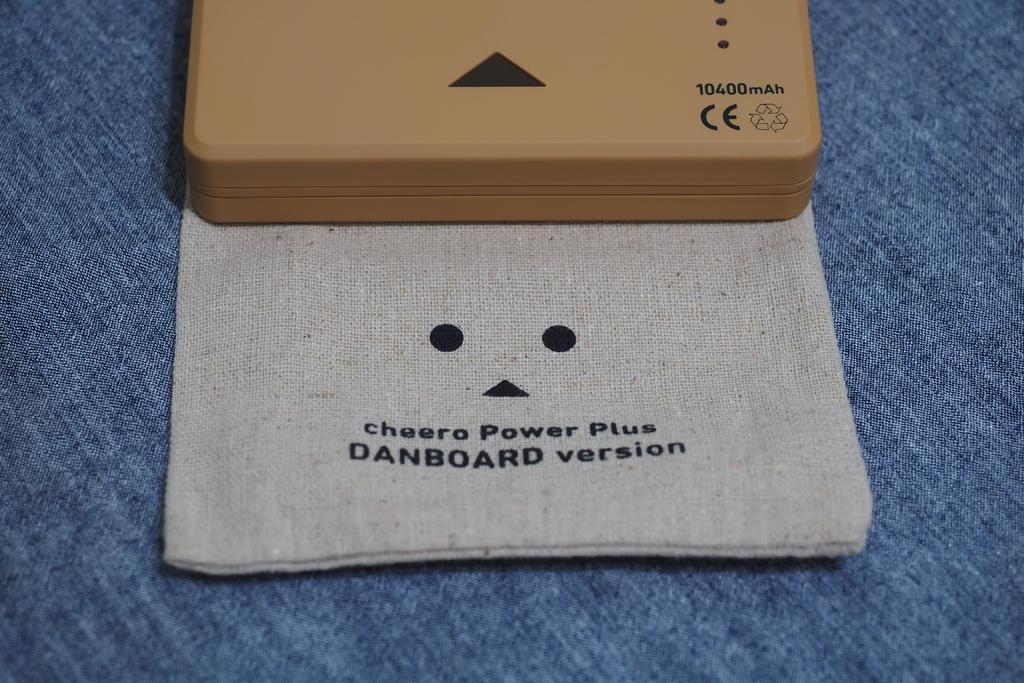What version is this?
Ensure brevity in your answer.  Danboard. What numbers are on the top section?
Ensure brevity in your answer.  10400. 